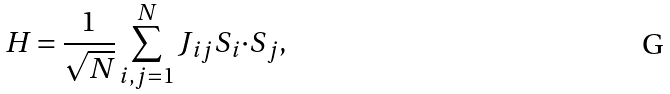Convert formula to latex. <formula><loc_0><loc_0><loc_500><loc_500>H = \frac { 1 } { \sqrt { N } } \sum _ { i , j = 1 } ^ { N } J _ { i j } { S } _ { i } { \cdot S } _ { j } ,</formula> 